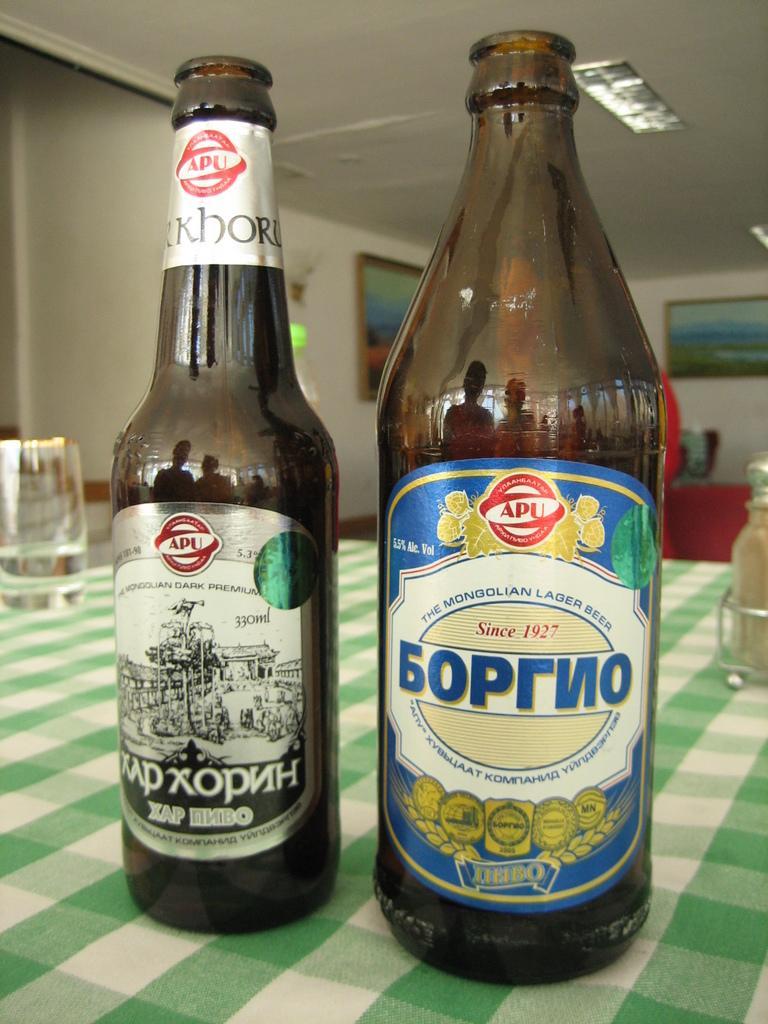Describe this image in one or two sentences. In this picture we can see two bottles with stickers on it, glass, jar and these are placed on a cloth and in the background we can see frames on the wall. 